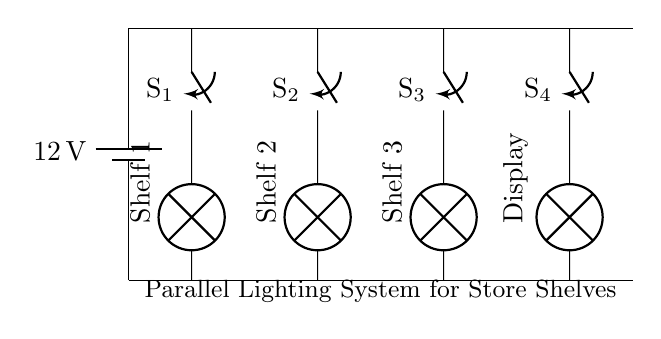What is the voltage of this circuit? The voltage is 12 volts, which is indicated by the battery symbol in the circuit diagram. This represents the potential difference supplied to the entire parallel lighting system.
Answer: 12 volts How many switches are present in the circuit? There are four switches in the circuit, each labeled with S1, S2, S3, and S4. They are connected in parallel to control the lamps on different shelves.
Answer: Four What is the purpose of the lamps in this circuit? The lamps serve to illuminate the store shelves and product displays. Each lamp is connected to a specific shelf or display and is turned on or off by its corresponding switch.
Answer: Illumination If all switches are closed, how many lamps will receive power? All four lamps will receive power because they are connected in parallel. In a parallel circuit, each component gets the same voltage from the power source, allowing all lamps to function simultaneously.
Answer: Four Which shelf is controlled by switch S3? Switch S3 controls Shelf 3, as indicated by the connection from S3 leading to the lamp associated with Shelf 3 in the circuit diagram.
Answer: Shelf 3 What type of circuit configuration is used for the lighting system? The circuit configuration used is parallel. This is evident because each lamp has its own branch and can operate independently when their corresponding switches are toggled.
Answer: Parallel 